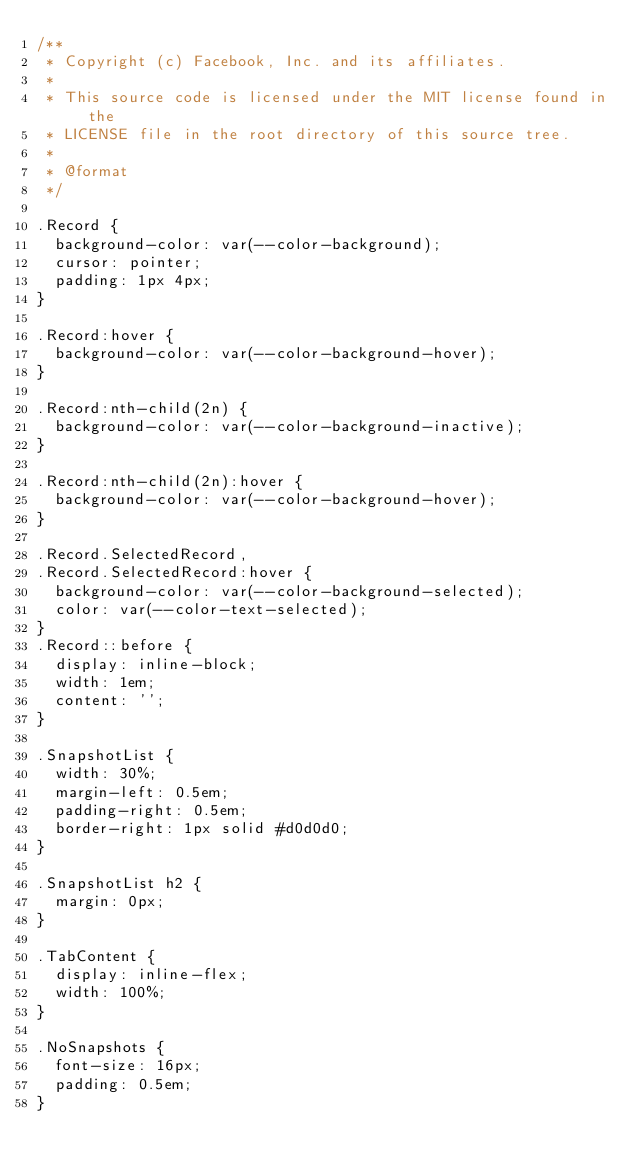<code> <loc_0><loc_0><loc_500><loc_500><_CSS_>/**
 * Copyright (c) Facebook, Inc. and its affiliates.
 *
 * This source code is licensed under the MIT license found in the
 * LICENSE file in the root directory of this source tree.
 *
 * @format
 */

.Record {
  background-color: var(--color-background);
  cursor: pointer;
  padding: 1px 4px;
}

.Record:hover {
  background-color: var(--color-background-hover);
}

.Record:nth-child(2n) {
  background-color: var(--color-background-inactive);
}

.Record:nth-child(2n):hover {
  background-color: var(--color-background-hover);
}

.Record.SelectedRecord,
.Record.SelectedRecord:hover {
  background-color: var(--color-background-selected);
  color: var(--color-text-selected);
}
.Record::before {
  display: inline-block;
  width: 1em;
  content: '';
}

.SnapshotList {
  width: 30%;
  margin-left: 0.5em;
  padding-right: 0.5em;
  border-right: 1px solid #d0d0d0;
}

.SnapshotList h2 {
  margin: 0px;
}

.TabContent {
  display: inline-flex;
  width: 100%;
}

.NoSnapshots {
  font-size: 16px;
  padding: 0.5em;
}
</code> 